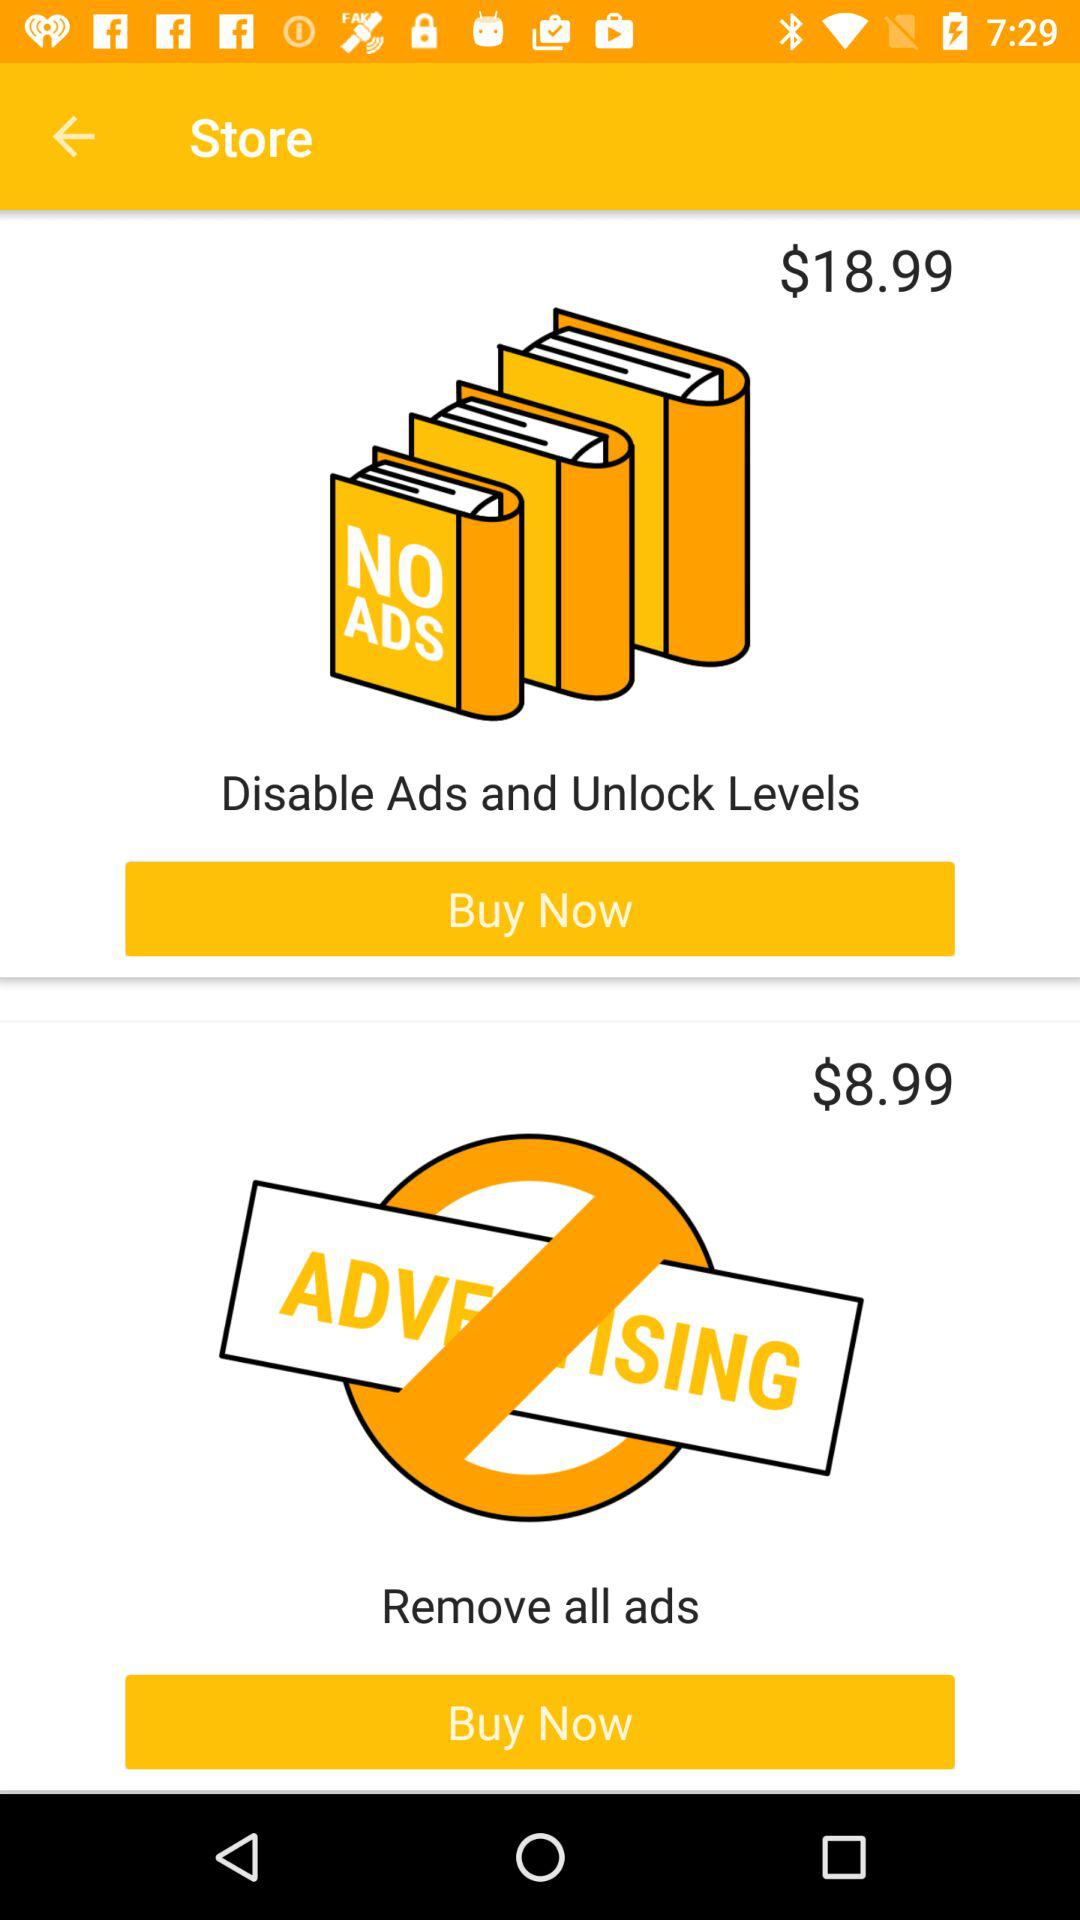What is the price of "Disable Ads and Unlock Levels"? The price is $18.99. 